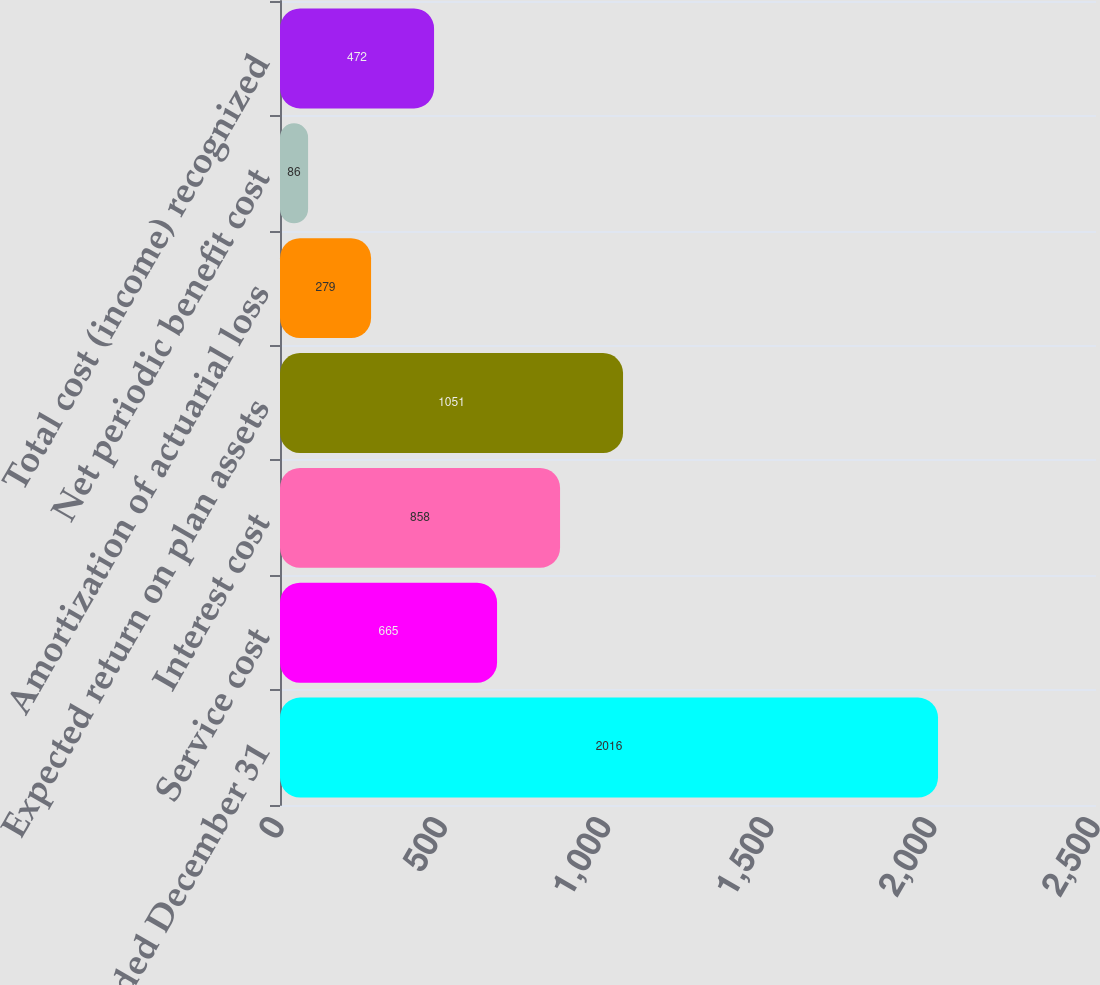Convert chart to OTSL. <chart><loc_0><loc_0><loc_500><loc_500><bar_chart><fcel>Year Ended December 31<fcel>Service cost<fcel>Interest cost<fcel>Expected return on plan assets<fcel>Amortization of actuarial loss<fcel>Net periodic benefit cost<fcel>Total cost (income) recognized<nl><fcel>2016<fcel>665<fcel>858<fcel>1051<fcel>279<fcel>86<fcel>472<nl></chart> 